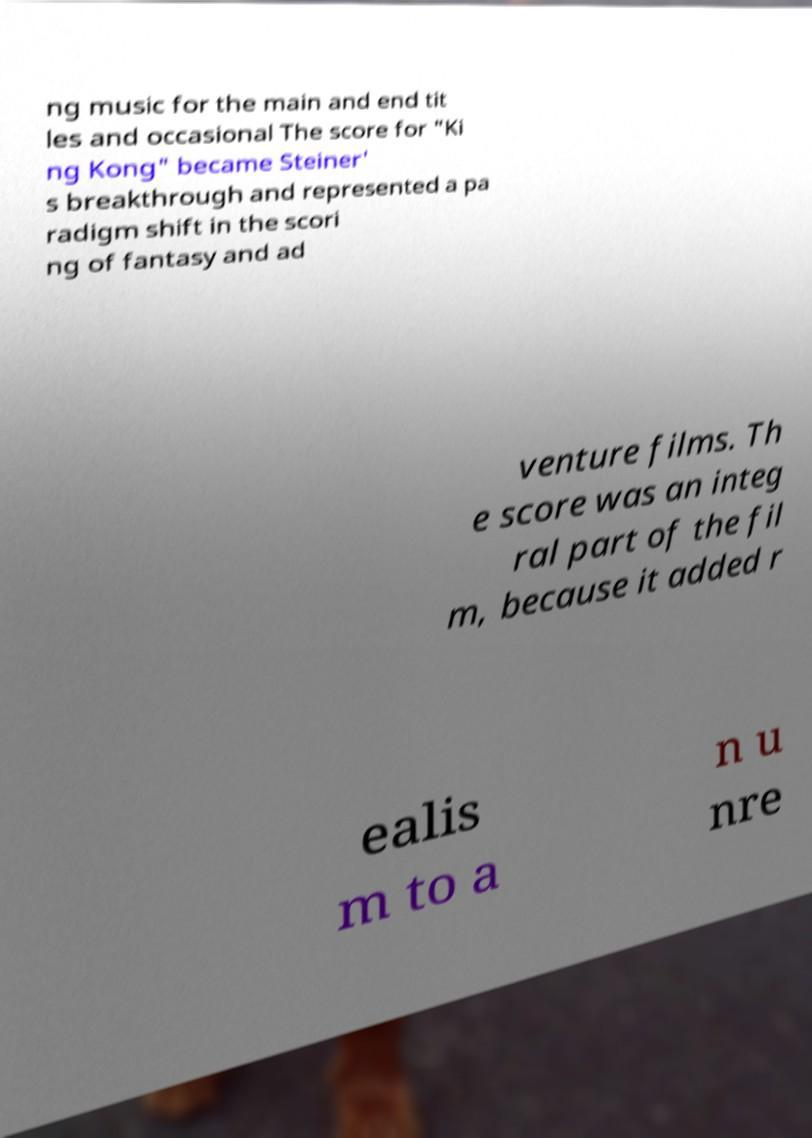Could you assist in decoding the text presented in this image and type it out clearly? ng music for the main and end tit les and occasional The score for "Ki ng Kong" became Steiner' s breakthrough and represented a pa radigm shift in the scori ng of fantasy and ad venture films. Th e score was an integ ral part of the fil m, because it added r ealis m to a n u nre 